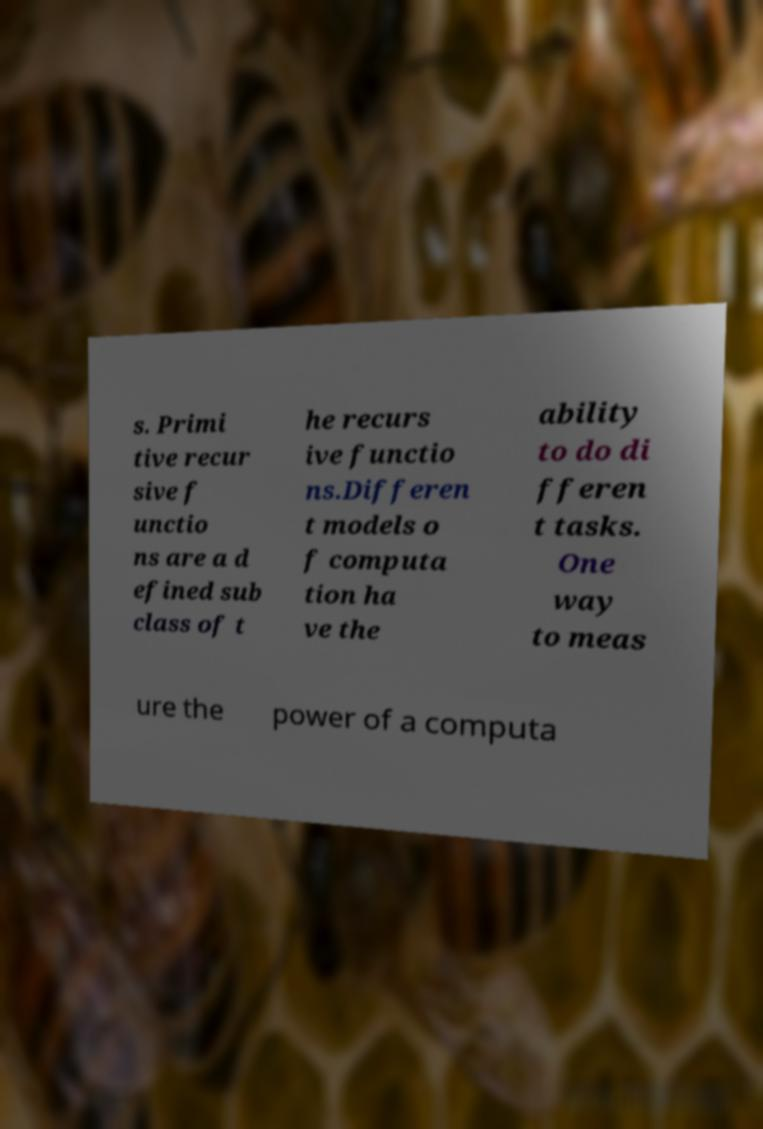I need the written content from this picture converted into text. Can you do that? s. Primi tive recur sive f unctio ns are a d efined sub class of t he recurs ive functio ns.Differen t models o f computa tion ha ve the ability to do di fferen t tasks. One way to meas ure the power of a computa 